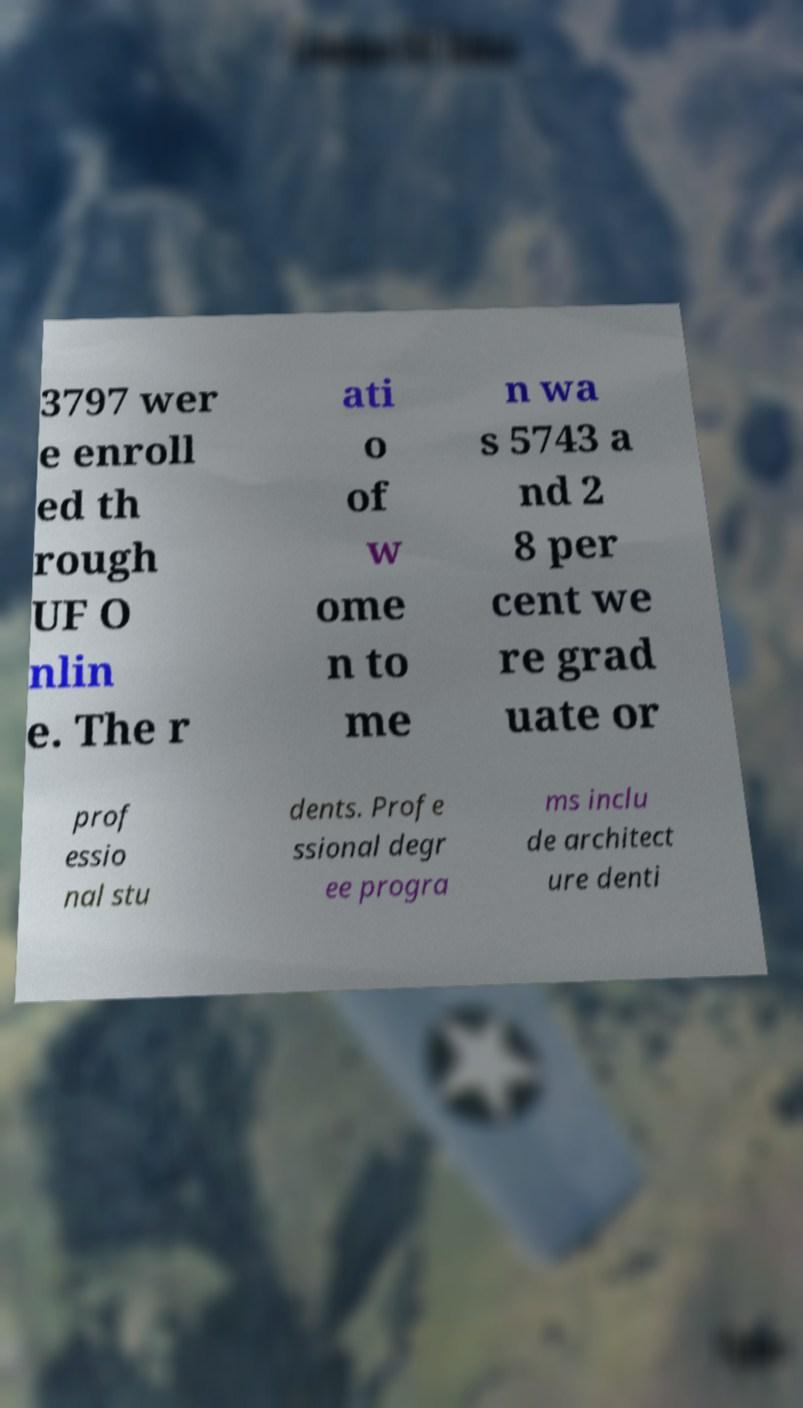Can you accurately transcribe the text from the provided image for me? 3797 wer e enroll ed th rough UF O nlin e. The r ati o of w ome n to me n wa s 5743 a nd 2 8 per cent we re grad uate or prof essio nal stu dents. Profe ssional degr ee progra ms inclu de architect ure denti 